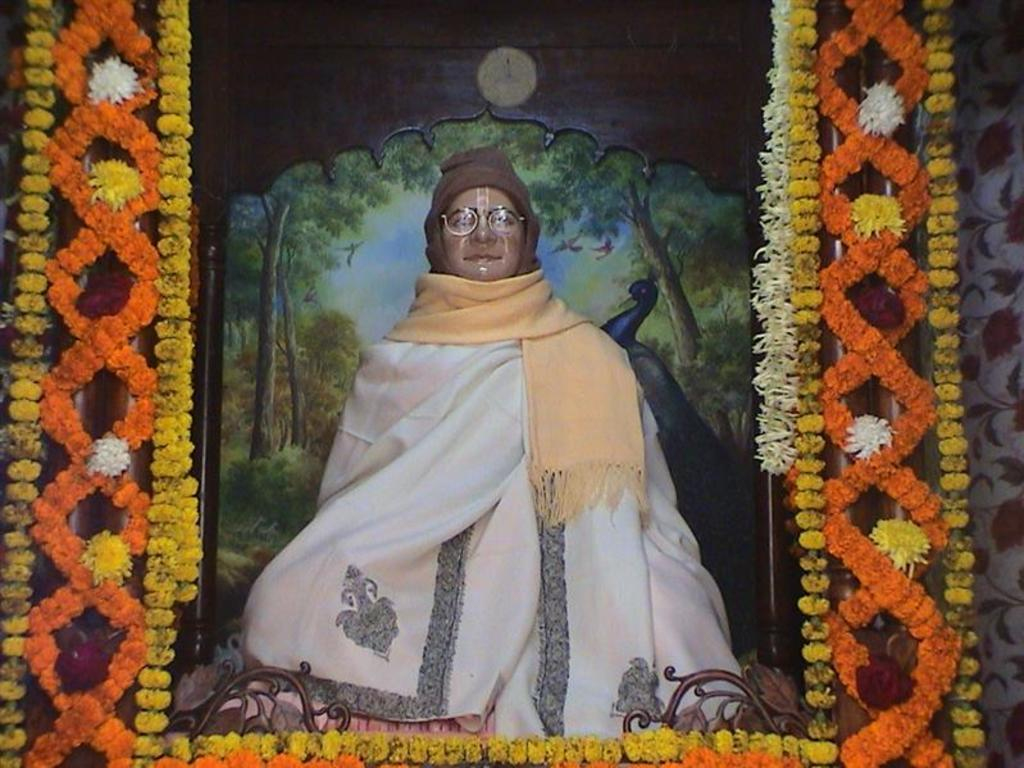What is the main subject of the image? There is a statue of a person in the image. What other objects can be seen in the image? There are flowers and garlands in the image. What is visible in the background of the image? There is a poster visible in the background of the image. What type of bells can be heard ringing in the image? There are no bells or sounds mentioned in the image, so it is not possible to determine if any bells are ringing. 